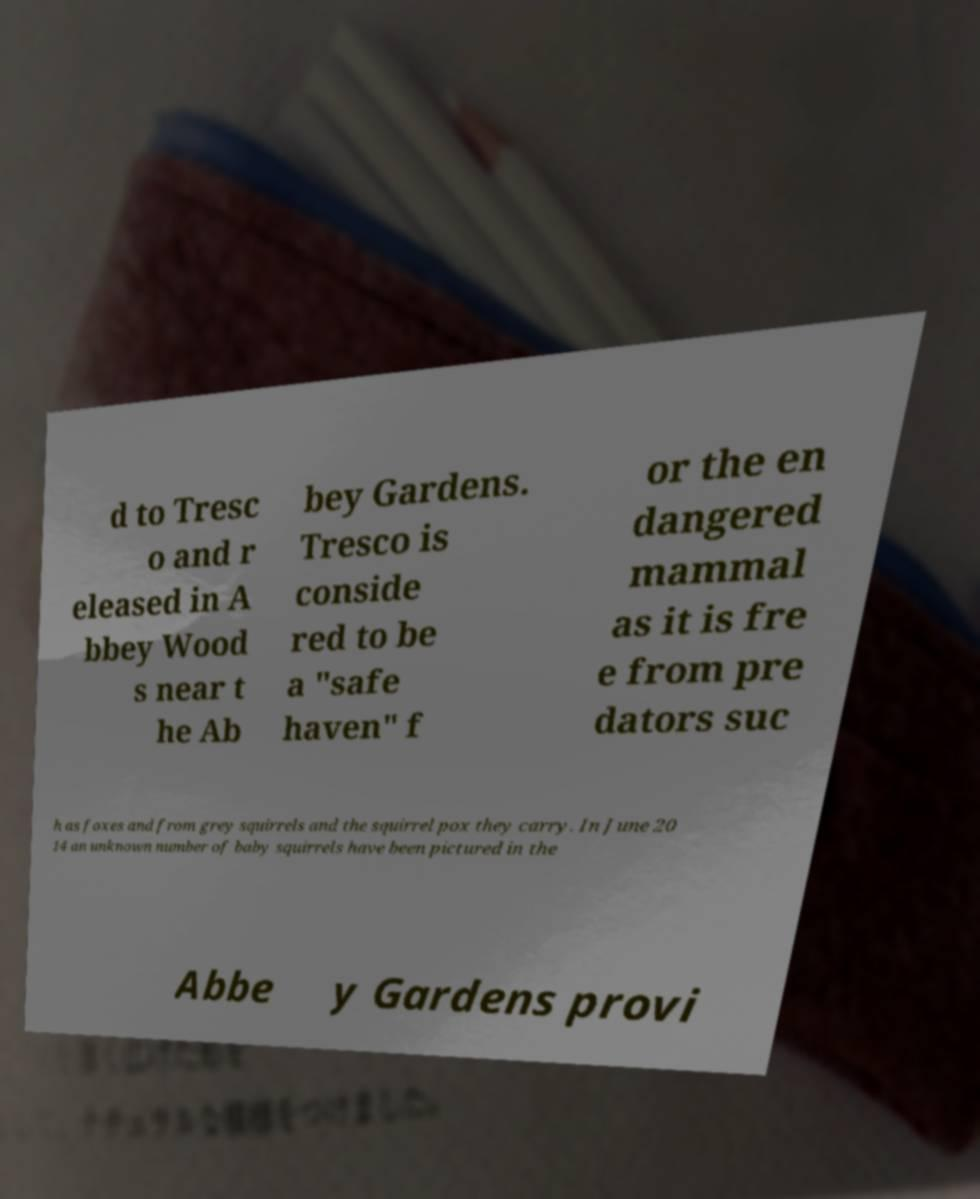Can you accurately transcribe the text from the provided image for me? d to Tresc o and r eleased in A bbey Wood s near t he Ab bey Gardens. Tresco is conside red to be a ″safe haven″ f or the en dangered mammal as it is fre e from pre dators suc h as foxes and from grey squirrels and the squirrel pox they carry. In June 20 14 an unknown number of baby squirrels have been pictured in the Abbe y Gardens provi 